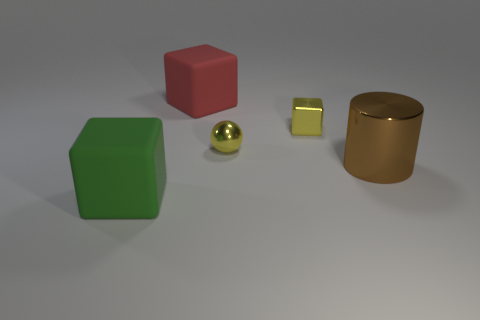How many other things are the same shape as the brown object?
Your answer should be very brief. 0. There is a metal cube that is behind the green cube; is its color the same as the ball?
Your response must be concise. Yes. What number of other things are there of the same size as the brown cylinder?
Offer a terse response. 2. Is the material of the red thing the same as the small ball?
Give a very brief answer. No. There is a object that is on the left side of the matte block that is behind the large cylinder; what color is it?
Your answer should be very brief. Green. What is the size of the red rubber object that is the same shape as the large green rubber thing?
Provide a succinct answer. Large. Does the tiny sphere have the same color as the tiny metallic cube?
Provide a succinct answer. Yes. What number of small yellow cubes are behind the big matte object behind the matte block to the left of the red block?
Provide a short and direct response. 0. Is the number of large brown metal cylinders greater than the number of small yellow rubber blocks?
Offer a very short reply. Yes. How many gray rubber objects are there?
Keep it short and to the point. 0. 